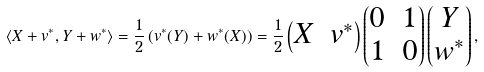Convert formula to latex. <formula><loc_0><loc_0><loc_500><loc_500>\langle X + v ^ { * } , Y + w ^ { * } \rangle = \frac { 1 } { 2 } \left ( v ^ { * } ( Y ) + w ^ { * } ( X ) \right ) = \frac { 1 } { 2 } \begin{pmatrix} X & v ^ { * } \end{pmatrix} \begin{pmatrix} 0 & 1 \\ 1 & 0 \end{pmatrix} \begin{pmatrix} Y \\ w ^ { * } \end{pmatrix} ,</formula> 